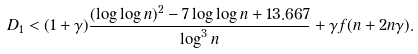<formula> <loc_0><loc_0><loc_500><loc_500>D _ { 1 } < ( 1 + \gamma ) \frac { ( \log \log n ) ^ { 2 } - 7 \log \log n + 1 3 . 6 6 7 } { \log ^ { 3 } n } + \gamma f ( n + 2 n \gamma ) .</formula> 